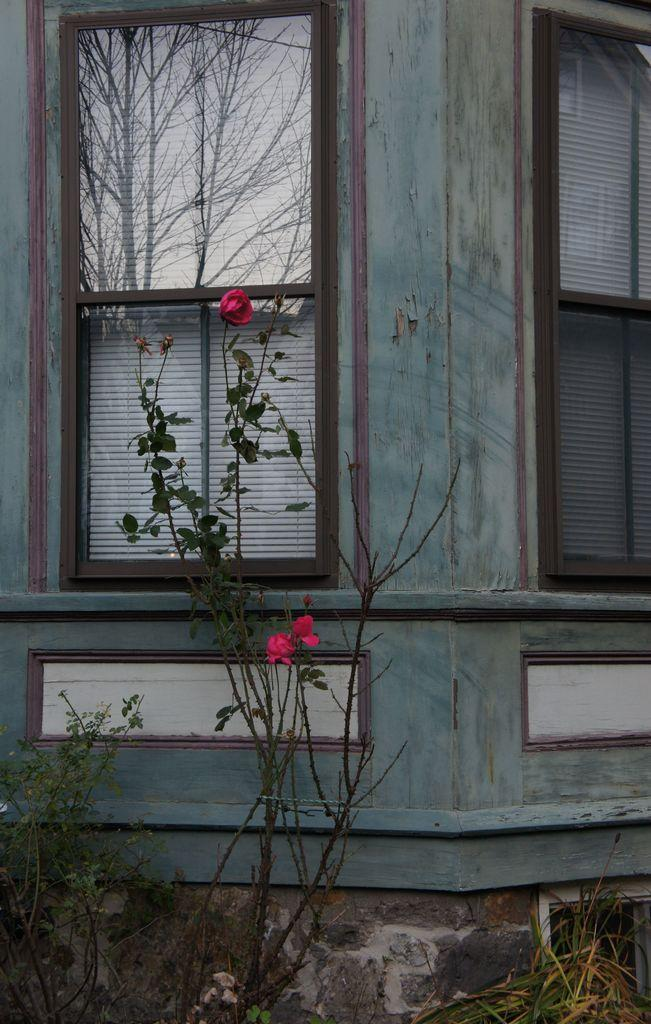What type of living organisms can be seen in the image? Plants can be seen in the image. What architectural feature is present in the image? There are windows in the image, which are part of a wall. What can be seen in the reflection of the windows? The reflection of trees and the sky is visible in the image. What is the level of shock experienced by the plants in the image? There is no indication of shock or any emotional state in the image, as plants do not have emotions. 